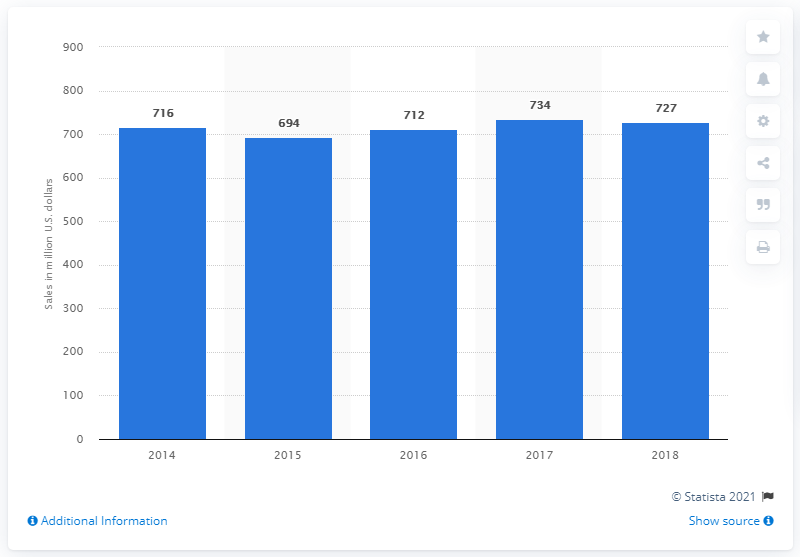Draw attention to some important aspects in this diagram. Jani-King's global sales in 2018 were 727 dollars. 